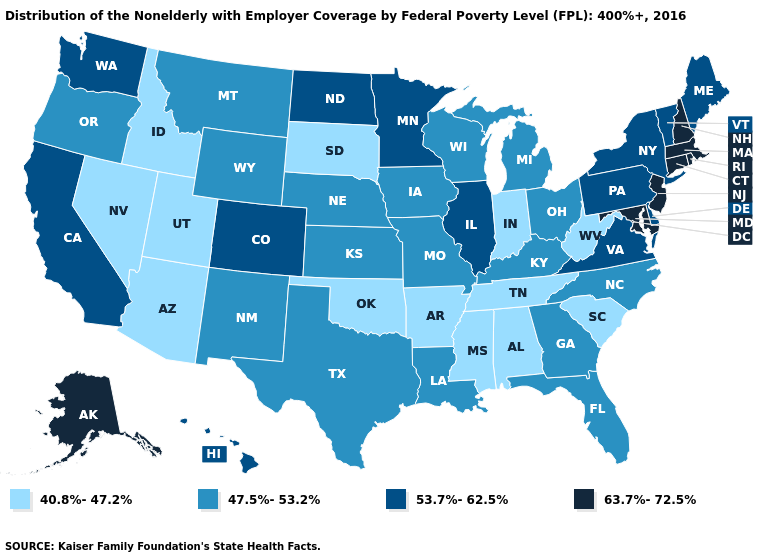Which states have the lowest value in the USA?
Concise answer only. Alabama, Arizona, Arkansas, Idaho, Indiana, Mississippi, Nevada, Oklahoma, South Carolina, South Dakota, Tennessee, Utah, West Virginia. What is the value of Alaska?
Quick response, please. 63.7%-72.5%. Does the first symbol in the legend represent the smallest category?
Write a very short answer. Yes. Does South Dakota have the lowest value in the USA?
Quick response, please. Yes. Which states have the highest value in the USA?
Be succinct. Alaska, Connecticut, Maryland, Massachusetts, New Hampshire, New Jersey, Rhode Island. What is the value of Louisiana?
Give a very brief answer. 47.5%-53.2%. Name the states that have a value in the range 53.7%-62.5%?
Give a very brief answer. California, Colorado, Delaware, Hawaii, Illinois, Maine, Minnesota, New York, North Dakota, Pennsylvania, Vermont, Virginia, Washington. Name the states that have a value in the range 40.8%-47.2%?
Keep it brief. Alabama, Arizona, Arkansas, Idaho, Indiana, Mississippi, Nevada, Oklahoma, South Carolina, South Dakota, Tennessee, Utah, West Virginia. What is the lowest value in the USA?
Answer briefly. 40.8%-47.2%. Among the states that border Oklahoma , which have the lowest value?
Give a very brief answer. Arkansas. What is the highest value in the USA?
Short answer required. 63.7%-72.5%. Does South Dakota have the lowest value in the USA?
Be succinct. Yes. Name the states that have a value in the range 47.5%-53.2%?
Short answer required. Florida, Georgia, Iowa, Kansas, Kentucky, Louisiana, Michigan, Missouri, Montana, Nebraska, New Mexico, North Carolina, Ohio, Oregon, Texas, Wisconsin, Wyoming. Does North Dakota have the highest value in the MidWest?
Keep it brief. Yes. What is the value of Massachusetts?
Give a very brief answer. 63.7%-72.5%. 